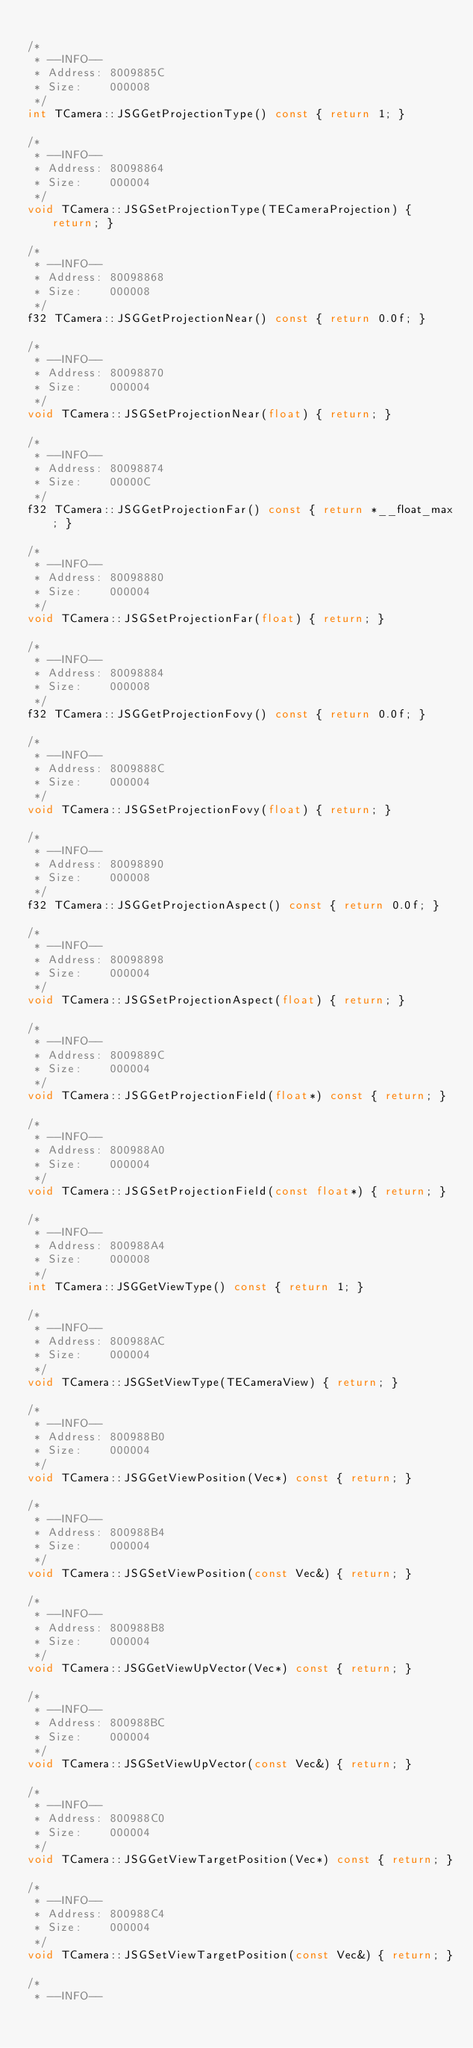<code> <loc_0><loc_0><loc_500><loc_500><_C++_>
/*
 * --INFO--
 * Address:	8009885C
 * Size:	000008
 */
int TCamera::JSGGetProjectionType() const { return 1; }

/*
 * --INFO--
 * Address:	80098864
 * Size:	000004
 */
void TCamera::JSGSetProjectionType(TECameraProjection) { return; }

/*
 * --INFO--
 * Address:	80098868
 * Size:	000008
 */
f32 TCamera::JSGGetProjectionNear() const { return 0.0f; }

/*
 * --INFO--
 * Address:	80098870
 * Size:	000004
 */
void TCamera::JSGSetProjectionNear(float) { return; }

/*
 * --INFO--
 * Address:	80098874
 * Size:	00000C
 */
f32 TCamera::JSGGetProjectionFar() const { return *__float_max; }

/*
 * --INFO--
 * Address:	80098880
 * Size:	000004
 */
void TCamera::JSGSetProjectionFar(float) { return; }

/*
 * --INFO--
 * Address:	80098884
 * Size:	000008
 */
f32 TCamera::JSGGetProjectionFovy() const { return 0.0f; }

/*
 * --INFO--
 * Address:	8009888C
 * Size:	000004
 */
void TCamera::JSGSetProjectionFovy(float) { return; }

/*
 * --INFO--
 * Address:	80098890
 * Size:	000008
 */
f32 TCamera::JSGGetProjectionAspect() const { return 0.0f; }

/*
 * --INFO--
 * Address:	80098898
 * Size:	000004
 */
void TCamera::JSGSetProjectionAspect(float) { return; }

/*
 * --INFO--
 * Address:	8009889C
 * Size:	000004
 */
void TCamera::JSGGetProjectionField(float*) const { return; }

/*
 * --INFO--
 * Address:	800988A0
 * Size:	000004
 */
void TCamera::JSGSetProjectionField(const float*) { return; }

/*
 * --INFO--
 * Address:	800988A4
 * Size:	000008
 */
int TCamera::JSGGetViewType() const { return 1; }

/*
 * --INFO--
 * Address:	800988AC
 * Size:	000004
 */
void TCamera::JSGSetViewType(TECameraView) { return; }

/*
 * --INFO--
 * Address:	800988B0
 * Size:	000004
 */
void TCamera::JSGGetViewPosition(Vec*) const { return; }

/*
 * --INFO--
 * Address:	800988B4
 * Size:	000004
 */
void TCamera::JSGSetViewPosition(const Vec&) { return; }

/*
 * --INFO--
 * Address:	800988B8
 * Size:	000004
 */
void TCamera::JSGGetViewUpVector(Vec*) const { return; }

/*
 * --INFO--
 * Address:	800988BC
 * Size:	000004
 */
void TCamera::JSGSetViewUpVector(const Vec&) { return; }

/*
 * --INFO--
 * Address:	800988C0
 * Size:	000004
 */
void TCamera::JSGGetViewTargetPosition(Vec*) const { return; }

/*
 * --INFO--
 * Address:	800988C4
 * Size:	000004
 */
void TCamera::JSGSetViewTargetPosition(const Vec&) { return; }

/*
 * --INFO--</code> 